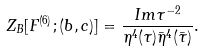Convert formula to latex. <formula><loc_0><loc_0><loc_500><loc_500>Z _ { B } [ F ^ { ( 6 ) } ; ( b , c ) ] = \frac { I m \tau ^ { - 2 } } { \eta ^ { 4 } ( \tau ) \bar { \eta } ^ { 4 } ( \bar { \tau } ) } .</formula> 